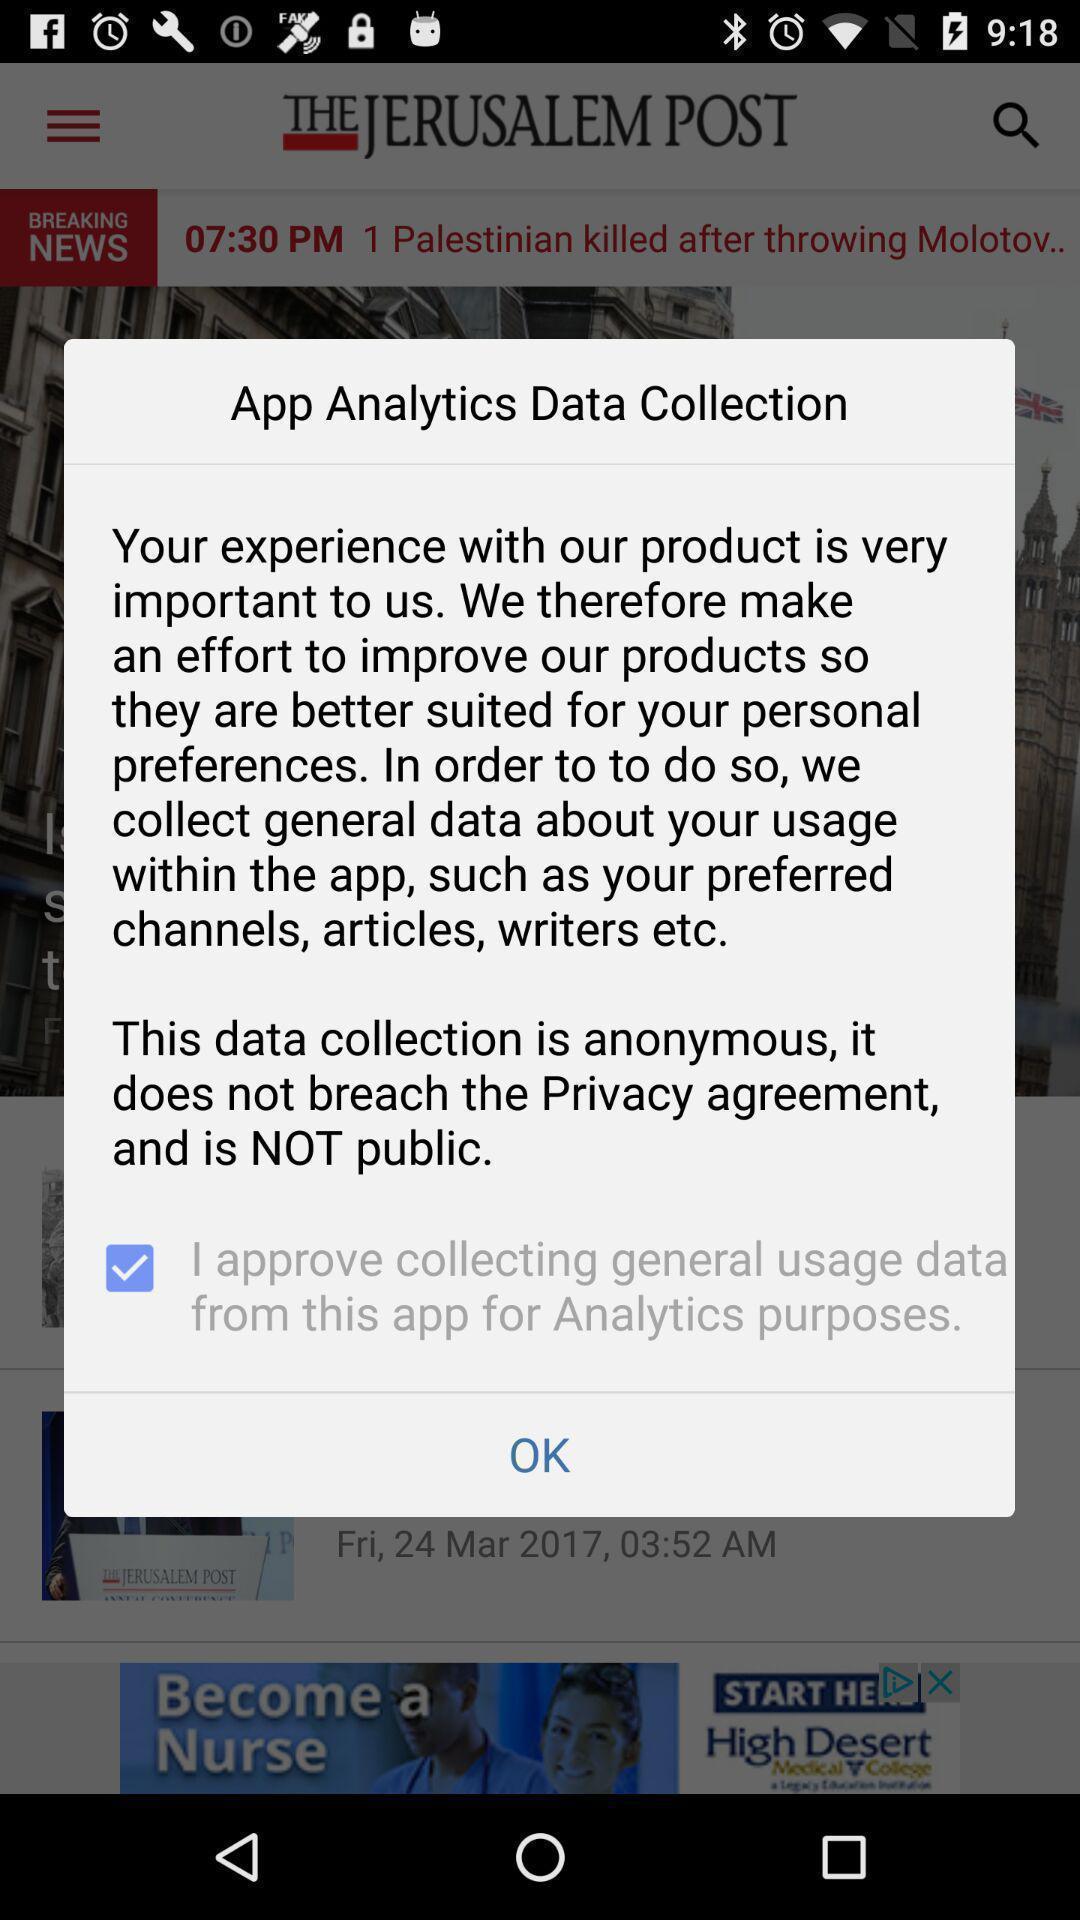Describe the key features of this screenshot. Popup displaying information about data collection. 